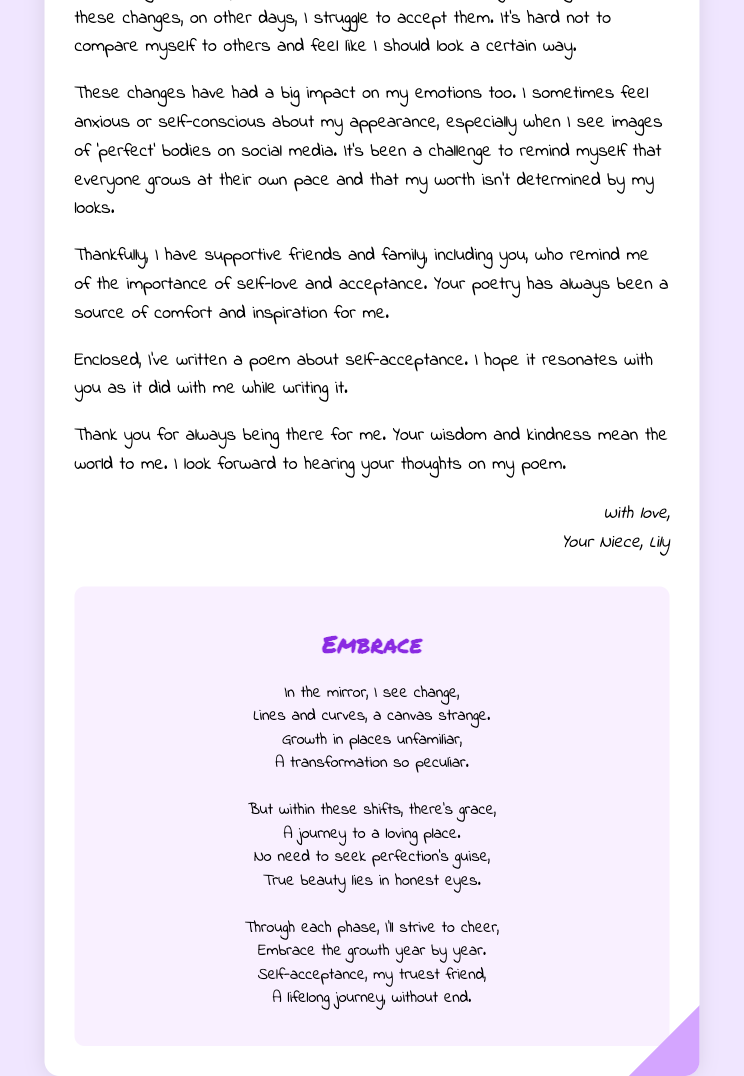What is the name of the writer? The writer of the letter is referred to as Lily in the closing signature.
Answer: Lily Who is the letter addressed to? The letter is addressed to Aunt Emily, as stated in the greeting.
Answer: Aunt Emily What emotion does Lily primarily express regarding her body changes? Lily mentions feeling anxious about her appearance, reflecting her emotional turmoil.
Answer: Anxious What theme does the enclosed poem focus on? The poem is centered around the idea of self-acceptance and embracing change.
Answer: Self-acceptance How many stanzas are in the poem? The poem contains four stanzas, as structured in the content.
Answer: Four What significant physical change has Lily experienced? Lily has noted a notable increase in her height as part of her physical growth.
Answer: Height Which artistic form does Lily mention as a source of comfort? Lily refers to poetry, specifically that of Aunt Emily, as comforting and inspirational.
Answer: Poetry What does Lily hope to hear from Aunt Emily? Lily expresses her desire to hear Aunt Emily's thoughts on her poem enclosed in the letter.
Answer: Thoughts on my poem 